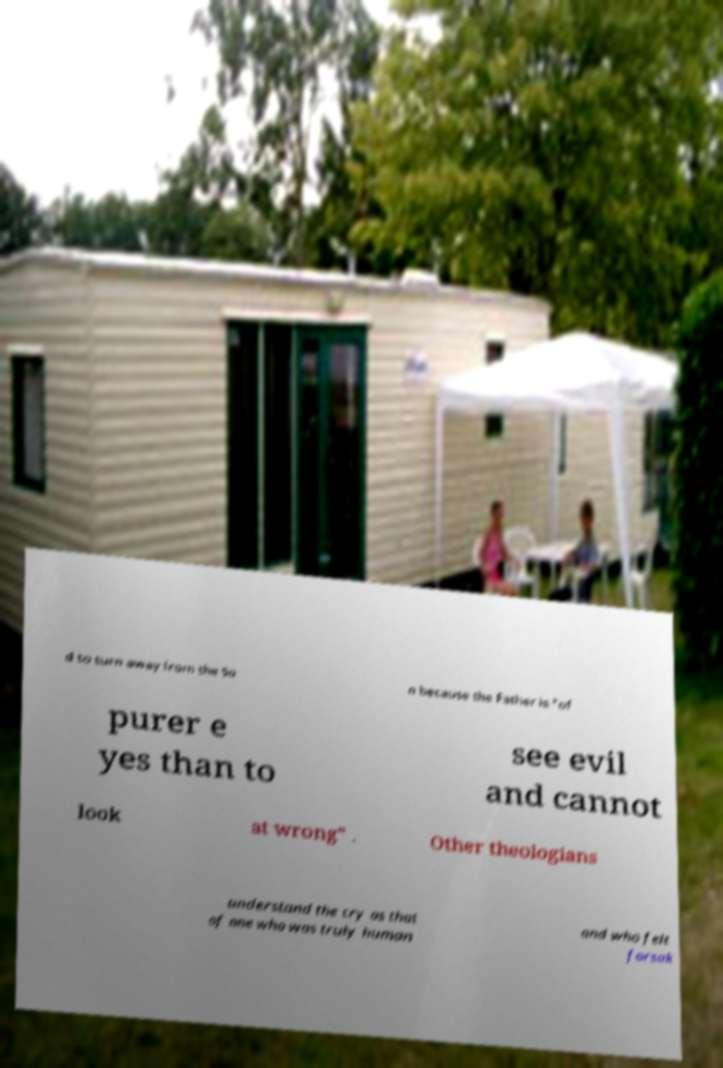What messages or text are displayed in this image? I need them in a readable, typed format. d to turn away from the So n because the Father is "of purer e yes than to see evil and cannot look at wrong" . Other theologians understand the cry as that of one who was truly human and who felt forsak 